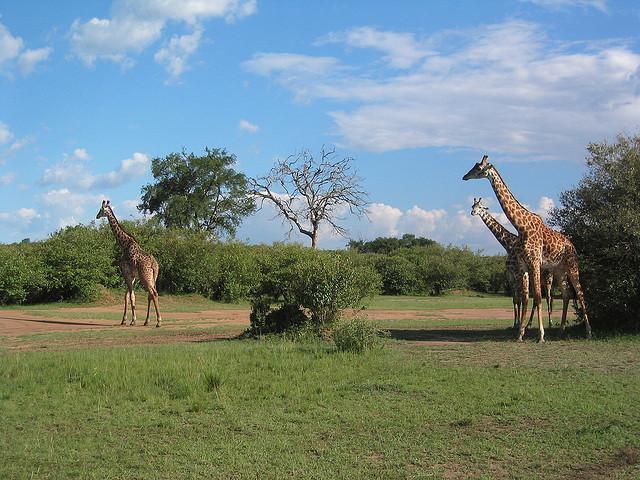How many giraffes are seen?
Give a very brief answer. 3. How many animals are in the picture?
Give a very brief answer. 3. How many giraffes are in this picture?
Give a very brief answer. 3. How many giraffes can be seen?
Give a very brief answer. 3. 